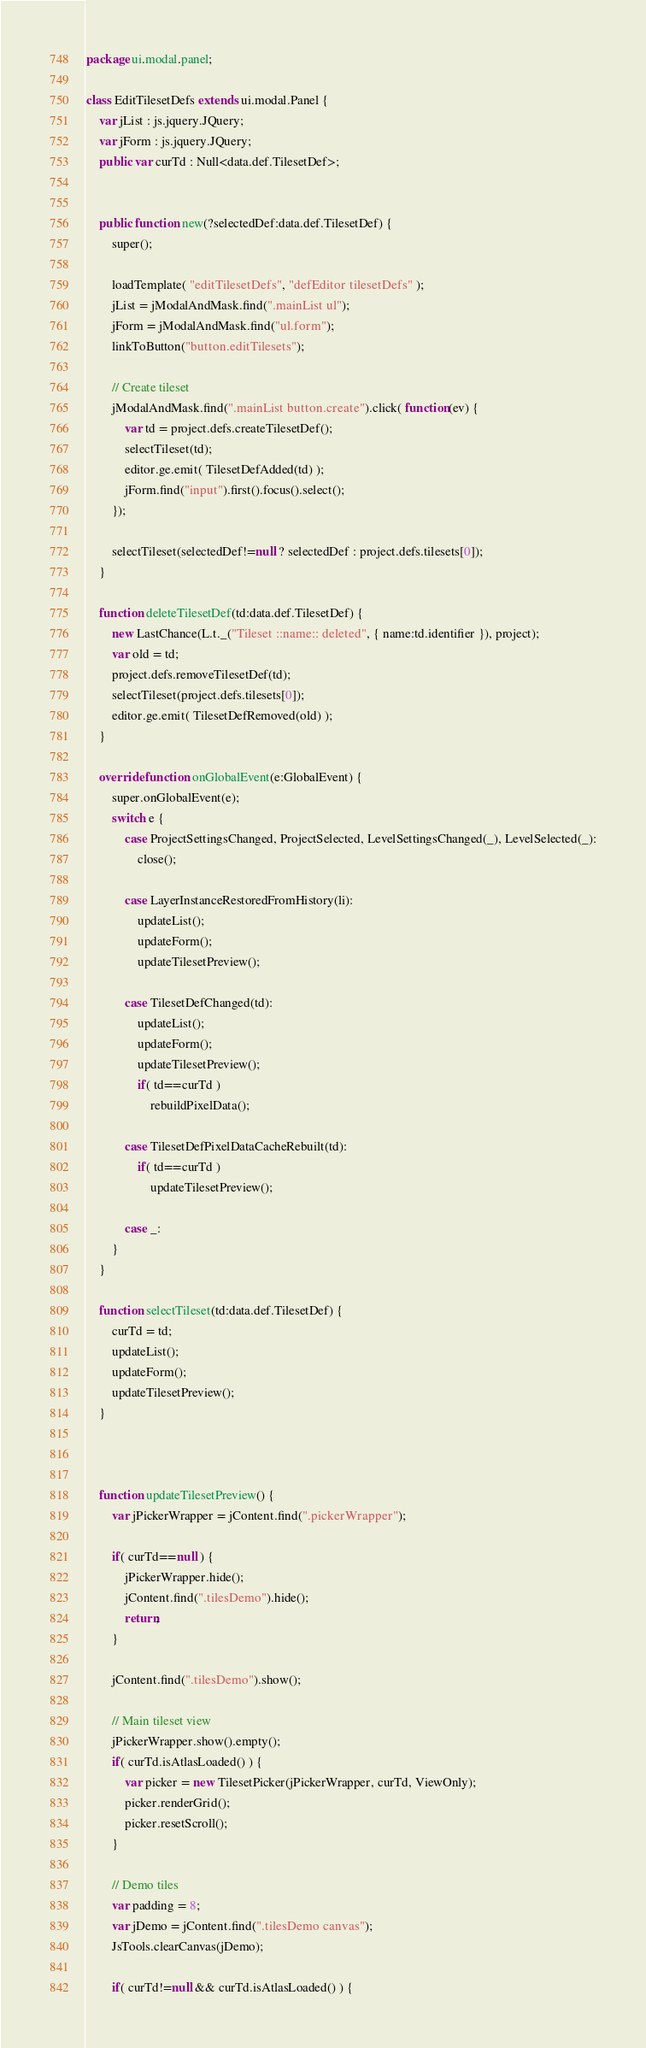Convert code to text. <code><loc_0><loc_0><loc_500><loc_500><_Haxe_>package ui.modal.panel;

class EditTilesetDefs extends ui.modal.Panel {
	var jList : js.jquery.JQuery;
	var jForm : js.jquery.JQuery;
	public var curTd : Null<data.def.TilesetDef>;


	public function new(?selectedDef:data.def.TilesetDef) {
		super();

		loadTemplate( "editTilesetDefs", "defEditor tilesetDefs" );
		jList = jModalAndMask.find(".mainList ul");
		jForm = jModalAndMask.find("ul.form");
		linkToButton("button.editTilesets");

		// Create tileset
		jModalAndMask.find(".mainList button.create").click( function(ev) {
			var td = project.defs.createTilesetDef();
			selectTileset(td);
			editor.ge.emit( TilesetDefAdded(td) );
			jForm.find("input").first().focus().select();
		});

		selectTileset(selectedDef!=null ? selectedDef : project.defs.tilesets[0]);
	}

	function deleteTilesetDef(td:data.def.TilesetDef) {
		new LastChance(L.t._("Tileset ::name:: deleted", { name:td.identifier }), project);
		var old = td;
		project.defs.removeTilesetDef(td);
		selectTileset(project.defs.tilesets[0]);
		editor.ge.emit( TilesetDefRemoved(old) );
	}

	override function onGlobalEvent(e:GlobalEvent) {
		super.onGlobalEvent(e);
		switch e {
			case ProjectSettingsChanged, ProjectSelected, LevelSettingsChanged(_), LevelSelected(_):
				close();

			case LayerInstanceRestoredFromHistory(li):
				updateList();
				updateForm();
				updateTilesetPreview();

			case TilesetDefChanged(td):
				updateList();
				updateForm();
				updateTilesetPreview();
				if( td==curTd )
					rebuildPixelData();

			case TilesetDefPixelDataCacheRebuilt(td):
				if( td==curTd )
					updateTilesetPreview();

			case _:
		}
	}

	function selectTileset(td:data.def.TilesetDef) {
		curTd = td;
		updateList();
		updateForm();
		updateTilesetPreview();
	}



	function updateTilesetPreview() {
		var jPickerWrapper = jContent.find(".pickerWrapper");

		if( curTd==null ) {
			jPickerWrapper.hide();
			jContent.find(".tilesDemo").hide();
			return;
		}

		jContent.find(".tilesDemo").show();

		// Main tileset view
		jPickerWrapper.show().empty();
		if( curTd.isAtlasLoaded() ) {
			var picker = new TilesetPicker(jPickerWrapper, curTd, ViewOnly);
			picker.renderGrid();
			picker.resetScroll();
		}

		// Demo tiles
		var padding = 8;
		var jDemo = jContent.find(".tilesDemo canvas");
		JsTools.clearCanvas(jDemo);

		if( curTd!=null && curTd.isAtlasLoaded() ) {</code> 